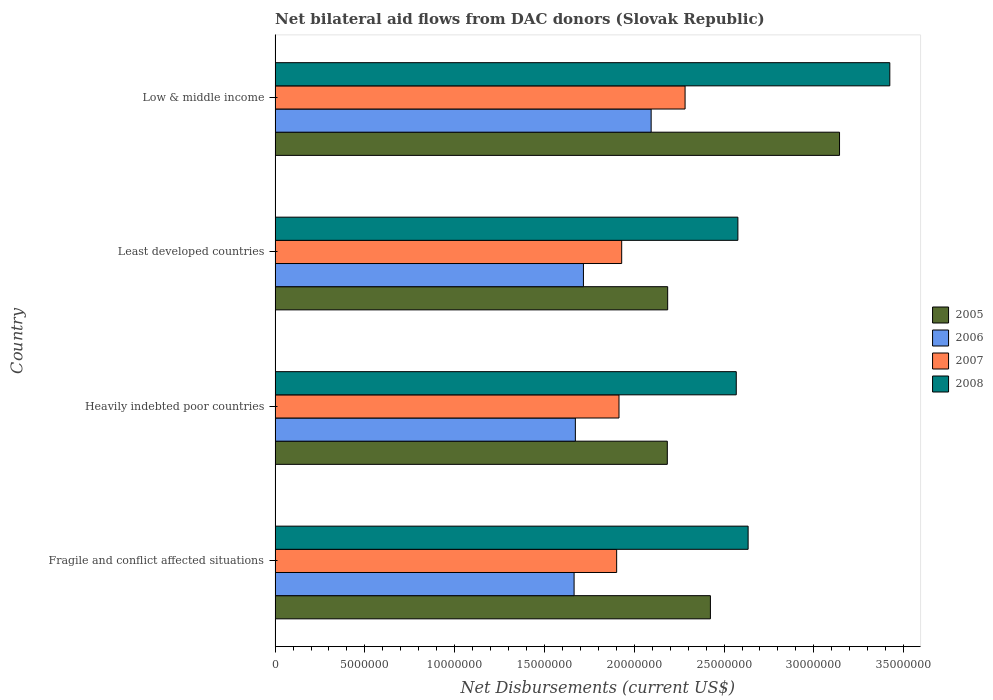How many different coloured bars are there?
Give a very brief answer. 4. Are the number of bars per tick equal to the number of legend labels?
Make the answer very short. Yes. Are the number of bars on each tick of the Y-axis equal?
Your answer should be very brief. Yes. How many bars are there on the 4th tick from the top?
Your response must be concise. 4. What is the label of the 4th group of bars from the top?
Provide a short and direct response. Fragile and conflict affected situations. What is the net bilateral aid flows in 2006 in Heavily indebted poor countries?
Offer a very short reply. 1.67e+07. Across all countries, what is the maximum net bilateral aid flows in 2008?
Offer a terse response. 3.42e+07. Across all countries, what is the minimum net bilateral aid flows in 2008?
Make the answer very short. 2.57e+07. In which country was the net bilateral aid flows in 2006 maximum?
Make the answer very short. Low & middle income. In which country was the net bilateral aid flows in 2006 minimum?
Ensure brevity in your answer.  Fragile and conflict affected situations. What is the total net bilateral aid flows in 2007 in the graph?
Your answer should be compact. 8.03e+07. What is the difference between the net bilateral aid flows in 2006 in Heavily indebted poor countries and that in Least developed countries?
Provide a short and direct response. -4.50e+05. What is the difference between the net bilateral aid flows in 2006 in Fragile and conflict affected situations and the net bilateral aid flows in 2005 in Least developed countries?
Provide a succinct answer. -5.21e+06. What is the average net bilateral aid flows in 2006 per country?
Your answer should be very brief. 1.79e+07. What is the difference between the net bilateral aid flows in 2005 and net bilateral aid flows in 2008 in Fragile and conflict affected situations?
Offer a very short reply. -2.10e+06. In how many countries, is the net bilateral aid flows in 2006 greater than 1000000 US$?
Ensure brevity in your answer.  4. What is the ratio of the net bilateral aid flows in 2005 in Least developed countries to that in Low & middle income?
Your answer should be very brief. 0.7. Is the net bilateral aid flows in 2007 in Fragile and conflict affected situations less than that in Least developed countries?
Your answer should be very brief. Yes. What is the difference between the highest and the second highest net bilateral aid flows in 2008?
Offer a very short reply. 7.89e+06. What is the difference between the highest and the lowest net bilateral aid flows in 2008?
Your response must be concise. 8.55e+06. In how many countries, is the net bilateral aid flows in 2006 greater than the average net bilateral aid flows in 2006 taken over all countries?
Your answer should be compact. 1. Is the sum of the net bilateral aid flows in 2008 in Fragile and conflict affected situations and Least developed countries greater than the maximum net bilateral aid flows in 2005 across all countries?
Offer a very short reply. Yes. Is it the case that in every country, the sum of the net bilateral aid flows in 2008 and net bilateral aid flows in 2007 is greater than the net bilateral aid flows in 2005?
Ensure brevity in your answer.  Yes. Are all the bars in the graph horizontal?
Offer a very short reply. Yes. Does the graph contain grids?
Your answer should be very brief. No. Where does the legend appear in the graph?
Offer a very short reply. Center right. What is the title of the graph?
Ensure brevity in your answer.  Net bilateral aid flows from DAC donors (Slovak Republic). Does "1961" appear as one of the legend labels in the graph?
Give a very brief answer. No. What is the label or title of the X-axis?
Make the answer very short. Net Disbursements (current US$). What is the Net Disbursements (current US$) in 2005 in Fragile and conflict affected situations?
Provide a succinct answer. 2.42e+07. What is the Net Disbursements (current US$) in 2006 in Fragile and conflict affected situations?
Provide a short and direct response. 1.66e+07. What is the Net Disbursements (current US$) in 2007 in Fragile and conflict affected situations?
Ensure brevity in your answer.  1.90e+07. What is the Net Disbursements (current US$) of 2008 in Fragile and conflict affected situations?
Your response must be concise. 2.63e+07. What is the Net Disbursements (current US$) in 2005 in Heavily indebted poor countries?
Your answer should be very brief. 2.18e+07. What is the Net Disbursements (current US$) of 2006 in Heavily indebted poor countries?
Offer a terse response. 1.67e+07. What is the Net Disbursements (current US$) in 2007 in Heavily indebted poor countries?
Offer a terse response. 1.92e+07. What is the Net Disbursements (current US$) in 2008 in Heavily indebted poor countries?
Offer a very short reply. 2.57e+07. What is the Net Disbursements (current US$) in 2005 in Least developed countries?
Make the answer very short. 2.19e+07. What is the Net Disbursements (current US$) of 2006 in Least developed countries?
Ensure brevity in your answer.  1.72e+07. What is the Net Disbursements (current US$) of 2007 in Least developed countries?
Make the answer very short. 1.93e+07. What is the Net Disbursements (current US$) in 2008 in Least developed countries?
Your response must be concise. 2.58e+07. What is the Net Disbursements (current US$) of 2005 in Low & middle income?
Keep it short and to the point. 3.14e+07. What is the Net Disbursements (current US$) in 2006 in Low & middle income?
Provide a succinct answer. 2.09e+07. What is the Net Disbursements (current US$) in 2007 in Low & middle income?
Your answer should be very brief. 2.28e+07. What is the Net Disbursements (current US$) in 2008 in Low & middle income?
Provide a succinct answer. 3.42e+07. Across all countries, what is the maximum Net Disbursements (current US$) of 2005?
Keep it short and to the point. 3.14e+07. Across all countries, what is the maximum Net Disbursements (current US$) of 2006?
Offer a very short reply. 2.09e+07. Across all countries, what is the maximum Net Disbursements (current US$) of 2007?
Offer a very short reply. 2.28e+07. Across all countries, what is the maximum Net Disbursements (current US$) in 2008?
Ensure brevity in your answer.  3.42e+07. Across all countries, what is the minimum Net Disbursements (current US$) of 2005?
Provide a short and direct response. 2.18e+07. Across all countries, what is the minimum Net Disbursements (current US$) of 2006?
Offer a terse response. 1.66e+07. Across all countries, what is the minimum Net Disbursements (current US$) in 2007?
Provide a succinct answer. 1.90e+07. Across all countries, what is the minimum Net Disbursements (current US$) in 2008?
Provide a succinct answer. 2.57e+07. What is the total Net Disbursements (current US$) in 2005 in the graph?
Make the answer very short. 9.94e+07. What is the total Net Disbursements (current US$) of 2006 in the graph?
Provide a succinct answer. 7.15e+07. What is the total Net Disbursements (current US$) of 2007 in the graph?
Provide a short and direct response. 8.03e+07. What is the total Net Disbursements (current US$) of 2008 in the graph?
Ensure brevity in your answer.  1.12e+08. What is the difference between the Net Disbursements (current US$) of 2005 in Fragile and conflict affected situations and that in Heavily indebted poor countries?
Provide a succinct answer. 2.40e+06. What is the difference between the Net Disbursements (current US$) in 2006 in Fragile and conflict affected situations and that in Heavily indebted poor countries?
Make the answer very short. -7.00e+04. What is the difference between the Net Disbursements (current US$) of 2007 in Fragile and conflict affected situations and that in Heavily indebted poor countries?
Provide a short and direct response. -1.30e+05. What is the difference between the Net Disbursements (current US$) of 2008 in Fragile and conflict affected situations and that in Heavily indebted poor countries?
Ensure brevity in your answer.  6.60e+05. What is the difference between the Net Disbursements (current US$) of 2005 in Fragile and conflict affected situations and that in Least developed countries?
Provide a succinct answer. 2.38e+06. What is the difference between the Net Disbursements (current US$) of 2006 in Fragile and conflict affected situations and that in Least developed countries?
Your answer should be very brief. -5.20e+05. What is the difference between the Net Disbursements (current US$) in 2007 in Fragile and conflict affected situations and that in Least developed countries?
Ensure brevity in your answer.  -2.80e+05. What is the difference between the Net Disbursements (current US$) of 2008 in Fragile and conflict affected situations and that in Least developed countries?
Make the answer very short. 5.70e+05. What is the difference between the Net Disbursements (current US$) in 2005 in Fragile and conflict affected situations and that in Low & middle income?
Provide a succinct answer. -7.19e+06. What is the difference between the Net Disbursements (current US$) in 2006 in Fragile and conflict affected situations and that in Low & middle income?
Offer a terse response. -4.29e+06. What is the difference between the Net Disbursements (current US$) of 2007 in Fragile and conflict affected situations and that in Low & middle income?
Offer a very short reply. -3.81e+06. What is the difference between the Net Disbursements (current US$) of 2008 in Fragile and conflict affected situations and that in Low & middle income?
Make the answer very short. -7.89e+06. What is the difference between the Net Disbursements (current US$) in 2006 in Heavily indebted poor countries and that in Least developed countries?
Give a very brief answer. -4.50e+05. What is the difference between the Net Disbursements (current US$) in 2007 in Heavily indebted poor countries and that in Least developed countries?
Provide a short and direct response. -1.50e+05. What is the difference between the Net Disbursements (current US$) in 2005 in Heavily indebted poor countries and that in Low & middle income?
Keep it short and to the point. -9.59e+06. What is the difference between the Net Disbursements (current US$) of 2006 in Heavily indebted poor countries and that in Low & middle income?
Offer a terse response. -4.22e+06. What is the difference between the Net Disbursements (current US$) in 2007 in Heavily indebted poor countries and that in Low & middle income?
Your answer should be very brief. -3.68e+06. What is the difference between the Net Disbursements (current US$) in 2008 in Heavily indebted poor countries and that in Low & middle income?
Ensure brevity in your answer.  -8.55e+06. What is the difference between the Net Disbursements (current US$) of 2005 in Least developed countries and that in Low & middle income?
Provide a short and direct response. -9.57e+06. What is the difference between the Net Disbursements (current US$) of 2006 in Least developed countries and that in Low & middle income?
Make the answer very short. -3.77e+06. What is the difference between the Net Disbursements (current US$) in 2007 in Least developed countries and that in Low & middle income?
Keep it short and to the point. -3.53e+06. What is the difference between the Net Disbursements (current US$) in 2008 in Least developed countries and that in Low & middle income?
Provide a succinct answer. -8.46e+06. What is the difference between the Net Disbursements (current US$) in 2005 in Fragile and conflict affected situations and the Net Disbursements (current US$) in 2006 in Heavily indebted poor countries?
Your answer should be compact. 7.52e+06. What is the difference between the Net Disbursements (current US$) of 2005 in Fragile and conflict affected situations and the Net Disbursements (current US$) of 2007 in Heavily indebted poor countries?
Your response must be concise. 5.09e+06. What is the difference between the Net Disbursements (current US$) of 2005 in Fragile and conflict affected situations and the Net Disbursements (current US$) of 2008 in Heavily indebted poor countries?
Provide a succinct answer. -1.44e+06. What is the difference between the Net Disbursements (current US$) of 2006 in Fragile and conflict affected situations and the Net Disbursements (current US$) of 2007 in Heavily indebted poor countries?
Your answer should be very brief. -2.50e+06. What is the difference between the Net Disbursements (current US$) of 2006 in Fragile and conflict affected situations and the Net Disbursements (current US$) of 2008 in Heavily indebted poor countries?
Provide a succinct answer. -9.03e+06. What is the difference between the Net Disbursements (current US$) of 2007 in Fragile and conflict affected situations and the Net Disbursements (current US$) of 2008 in Heavily indebted poor countries?
Your answer should be very brief. -6.66e+06. What is the difference between the Net Disbursements (current US$) of 2005 in Fragile and conflict affected situations and the Net Disbursements (current US$) of 2006 in Least developed countries?
Keep it short and to the point. 7.07e+06. What is the difference between the Net Disbursements (current US$) in 2005 in Fragile and conflict affected situations and the Net Disbursements (current US$) in 2007 in Least developed countries?
Your answer should be compact. 4.94e+06. What is the difference between the Net Disbursements (current US$) of 2005 in Fragile and conflict affected situations and the Net Disbursements (current US$) of 2008 in Least developed countries?
Make the answer very short. -1.53e+06. What is the difference between the Net Disbursements (current US$) of 2006 in Fragile and conflict affected situations and the Net Disbursements (current US$) of 2007 in Least developed countries?
Your answer should be very brief. -2.65e+06. What is the difference between the Net Disbursements (current US$) in 2006 in Fragile and conflict affected situations and the Net Disbursements (current US$) in 2008 in Least developed countries?
Your answer should be compact. -9.12e+06. What is the difference between the Net Disbursements (current US$) of 2007 in Fragile and conflict affected situations and the Net Disbursements (current US$) of 2008 in Least developed countries?
Offer a terse response. -6.75e+06. What is the difference between the Net Disbursements (current US$) in 2005 in Fragile and conflict affected situations and the Net Disbursements (current US$) in 2006 in Low & middle income?
Offer a very short reply. 3.30e+06. What is the difference between the Net Disbursements (current US$) of 2005 in Fragile and conflict affected situations and the Net Disbursements (current US$) of 2007 in Low & middle income?
Keep it short and to the point. 1.41e+06. What is the difference between the Net Disbursements (current US$) of 2005 in Fragile and conflict affected situations and the Net Disbursements (current US$) of 2008 in Low & middle income?
Give a very brief answer. -9.99e+06. What is the difference between the Net Disbursements (current US$) of 2006 in Fragile and conflict affected situations and the Net Disbursements (current US$) of 2007 in Low & middle income?
Offer a very short reply. -6.18e+06. What is the difference between the Net Disbursements (current US$) of 2006 in Fragile and conflict affected situations and the Net Disbursements (current US$) of 2008 in Low & middle income?
Give a very brief answer. -1.76e+07. What is the difference between the Net Disbursements (current US$) in 2007 in Fragile and conflict affected situations and the Net Disbursements (current US$) in 2008 in Low & middle income?
Provide a succinct answer. -1.52e+07. What is the difference between the Net Disbursements (current US$) in 2005 in Heavily indebted poor countries and the Net Disbursements (current US$) in 2006 in Least developed countries?
Give a very brief answer. 4.67e+06. What is the difference between the Net Disbursements (current US$) of 2005 in Heavily indebted poor countries and the Net Disbursements (current US$) of 2007 in Least developed countries?
Keep it short and to the point. 2.54e+06. What is the difference between the Net Disbursements (current US$) of 2005 in Heavily indebted poor countries and the Net Disbursements (current US$) of 2008 in Least developed countries?
Offer a very short reply. -3.93e+06. What is the difference between the Net Disbursements (current US$) in 2006 in Heavily indebted poor countries and the Net Disbursements (current US$) in 2007 in Least developed countries?
Your answer should be compact. -2.58e+06. What is the difference between the Net Disbursements (current US$) of 2006 in Heavily indebted poor countries and the Net Disbursements (current US$) of 2008 in Least developed countries?
Your answer should be compact. -9.05e+06. What is the difference between the Net Disbursements (current US$) of 2007 in Heavily indebted poor countries and the Net Disbursements (current US$) of 2008 in Least developed countries?
Offer a very short reply. -6.62e+06. What is the difference between the Net Disbursements (current US$) in 2005 in Heavily indebted poor countries and the Net Disbursements (current US$) in 2007 in Low & middle income?
Your answer should be compact. -9.90e+05. What is the difference between the Net Disbursements (current US$) in 2005 in Heavily indebted poor countries and the Net Disbursements (current US$) in 2008 in Low & middle income?
Offer a terse response. -1.24e+07. What is the difference between the Net Disbursements (current US$) in 2006 in Heavily indebted poor countries and the Net Disbursements (current US$) in 2007 in Low & middle income?
Give a very brief answer. -6.11e+06. What is the difference between the Net Disbursements (current US$) of 2006 in Heavily indebted poor countries and the Net Disbursements (current US$) of 2008 in Low & middle income?
Make the answer very short. -1.75e+07. What is the difference between the Net Disbursements (current US$) of 2007 in Heavily indebted poor countries and the Net Disbursements (current US$) of 2008 in Low & middle income?
Your answer should be compact. -1.51e+07. What is the difference between the Net Disbursements (current US$) in 2005 in Least developed countries and the Net Disbursements (current US$) in 2006 in Low & middle income?
Make the answer very short. 9.20e+05. What is the difference between the Net Disbursements (current US$) of 2005 in Least developed countries and the Net Disbursements (current US$) of 2007 in Low & middle income?
Give a very brief answer. -9.70e+05. What is the difference between the Net Disbursements (current US$) in 2005 in Least developed countries and the Net Disbursements (current US$) in 2008 in Low & middle income?
Ensure brevity in your answer.  -1.24e+07. What is the difference between the Net Disbursements (current US$) in 2006 in Least developed countries and the Net Disbursements (current US$) in 2007 in Low & middle income?
Give a very brief answer. -5.66e+06. What is the difference between the Net Disbursements (current US$) of 2006 in Least developed countries and the Net Disbursements (current US$) of 2008 in Low & middle income?
Provide a short and direct response. -1.71e+07. What is the difference between the Net Disbursements (current US$) of 2007 in Least developed countries and the Net Disbursements (current US$) of 2008 in Low & middle income?
Your answer should be very brief. -1.49e+07. What is the average Net Disbursements (current US$) in 2005 per country?
Keep it short and to the point. 2.48e+07. What is the average Net Disbursements (current US$) in 2006 per country?
Keep it short and to the point. 1.79e+07. What is the average Net Disbursements (current US$) in 2007 per country?
Provide a short and direct response. 2.01e+07. What is the average Net Disbursements (current US$) of 2008 per country?
Make the answer very short. 2.80e+07. What is the difference between the Net Disbursements (current US$) in 2005 and Net Disbursements (current US$) in 2006 in Fragile and conflict affected situations?
Your answer should be compact. 7.59e+06. What is the difference between the Net Disbursements (current US$) in 2005 and Net Disbursements (current US$) in 2007 in Fragile and conflict affected situations?
Offer a terse response. 5.22e+06. What is the difference between the Net Disbursements (current US$) in 2005 and Net Disbursements (current US$) in 2008 in Fragile and conflict affected situations?
Offer a terse response. -2.10e+06. What is the difference between the Net Disbursements (current US$) in 2006 and Net Disbursements (current US$) in 2007 in Fragile and conflict affected situations?
Your answer should be very brief. -2.37e+06. What is the difference between the Net Disbursements (current US$) in 2006 and Net Disbursements (current US$) in 2008 in Fragile and conflict affected situations?
Your answer should be compact. -9.69e+06. What is the difference between the Net Disbursements (current US$) of 2007 and Net Disbursements (current US$) of 2008 in Fragile and conflict affected situations?
Offer a terse response. -7.32e+06. What is the difference between the Net Disbursements (current US$) of 2005 and Net Disbursements (current US$) of 2006 in Heavily indebted poor countries?
Offer a terse response. 5.12e+06. What is the difference between the Net Disbursements (current US$) in 2005 and Net Disbursements (current US$) in 2007 in Heavily indebted poor countries?
Offer a terse response. 2.69e+06. What is the difference between the Net Disbursements (current US$) of 2005 and Net Disbursements (current US$) of 2008 in Heavily indebted poor countries?
Your response must be concise. -3.84e+06. What is the difference between the Net Disbursements (current US$) of 2006 and Net Disbursements (current US$) of 2007 in Heavily indebted poor countries?
Your answer should be very brief. -2.43e+06. What is the difference between the Net Disbursements (current US$) of 2006 and Net Disbursements (current US$) of 2008 in Heavily indebted poor countries?
Offer a terse response. -8.96e+06. What is the difference between the Net Disbursements (current US$) in 2007 and Net Disbursements (current US$) in 2008 in Heavily indebted poor countries?
Keep it short and to the point. -6.53e+06. What is the difference between the Net Disbursements (current US$) in 2005 and Net Disbursements (current US$) in 2006 in Least developed countries?
Your answer should be compact. 4.69e+06. What is the difference between the Net Disbursements (current US$) in 2005 and Net Disbursements (current US$) in 2007 in Least developed countries?
Provide a succinct answer. 2.56e+06. What is the difference between the Net Disbursements (current US$) of 2005 and Net Disbursements (current US$) of 2008 in Least developed countries?
Keep it short and to the point. -3.91e+06. What is the difference between the Net Disbursements (current US$) of 2006 and Net Disbursements (current US$) of 2007 in Least developed countries?
Give a very brief answer. -2.13e+06. What is the difference between the Net Disbursements (current US$) of 2006 and Net Disbursements (current US$) of 2008 in Least developed countries?
Keep it short and to the point. -8.60e+06. What is the difference between the Net Disbursements (current US$) in 2007 and Net Disbursements (current US$) in 2008 in Least developed countries?
Your answer should be very brief. -6.47e+06. What is the difference between the Net Disbursements (current US$) in 2005 and Net Disbursements (current US$) in 2006 in Low & middle income?
Offer a very short reply. 1.05e+07. What is the difference between the Net Disbursements (current US$) in 2005 and Net Disbursements (current US$) in 2007 in Low & middle income?
Make the answer very short. 8.60e+06. What is the difference between the Net Disbursements (current US$) of 2005 and Net Disbursements (current US$) of 2008 in Low & middle income?
Your answer should be very brief. -2.80e+06. What is the difference between the Net Disbursements (current US$) in 2006 and Net Disbursements (current US$) in 2007 in Low & middle income?
Give a very brief answer. -1.89e+06. What is the difference between the Net Disbursements (current US$) of 2006 and Net Disbursements (current US$) of 2008 in Low & middle income?
Make the answer very short. -1.33e+07. What is the difference between the Net Disbursements (current US$) of 2007 and Net Disbursements (current US$) of 2008 in Low & middle income?
Offer a terse response. -1.14e+07. What is the ratio of the Net Disbursements (current US$) in 2005 in Fragile and conflict affected situations to that in Heavily indebted poor countries?
Your response must be concise. 1.11. What is the ratio of the Net Disbursements (current US$) of 2006 in Fragile and conflict affected situations to that in Heavily indebted poor countries?
Keep it short and to the point. 1. What is the ratio of the Net Disbursements (current US$) in 2007 in Fragile and conflict affected situations to that in Heavily indebted poor countries?
Offer a very short reply. 0.99. What is the ratio of the Net Disbursements (current US$) in 2008 in Fragile and conflict affected situations to that in Heavily indebted poor countries?
Offer a very short reply. 1.03. What is the ratio of the Net Disbursements (current US$) of 2005 in Fragile and conflict affected situations to that in Least developed countries?
Your response must be concise. 1.11. What is the ratio of the Net Disbursements (current US$) of 2006 in Fragile and conflict affected situations to that in Least developed countries?
Offer a terse response. 0.97. What is the ratio of the Net Disbursements (current US$) of 2007 in Fragile and conflict affected situations to that in Least developed countries?
Offer a very short reply. 0.99. What is the ratio of the Net Disbursements (current US$) of 2008 in Fragile and conflict affected situations to that in Least developed countries?
Your answer should be very brief. 1.02. What is the ratio of the Net Disbursements (current US$) in 2005 in Fragile and conflict affected situations to that in Low & middle income?
Offer a very short reply. 0.77. What is the ratio of the Net Disbursements (current US$) of 2006 in Fragile and conflict affected situations to that in Low & middle income?
Ensure brevity in your answer.  0.8. What is the ratio of the Net Disbursements (current US$) in 2007 in Fragile and conflict affected situations to that in Low & middle income?
Ensure brevity in your answer.  0.83. What is the ratio of the Net Disbursements (current US$) in 2008 in Fragile and conflict affected situations to that in Low & middle income?
Provide a succinct answer. 0.77. What is the ratio of the Net Disbursements (current US$) of 2006 in Heavily indebted poor countries to that in Least developed countries?
Ensure brevity in your answer.  0.97. What is the ratio of the Net Disbursements (current US$) in 2007 in Heavily indebted poor countries to that in Least developed countries?
Offer a terse response. 0.99. What is the ratio of the Net Disbursements (current US$) in 2005 in Heavily indebted poor countries to that in Low & middle income?
Provide a short and direct response. 0.69. What is the ratio of the Net Disbursements (current US$) of 2006 in Heavily indebted poor countries to that in Low & middle income?
Your answer should be compact. 0.8. What is the ratio of the Net Disbursements (current US$) in 2007 in Heavily indebted poor countries to that in Low & middle income?
Provide a short and direct response. 0.84. What is the ratio of the Net Disbursements (current US$) in 2008 in Heavily indebted poor countries to that in Low & middle income?
Your answer should be very brief. 0.75. What is the ratio of the Net Disbursements (current US$) in 2005 in Least developed countries to that in Low & middle income?
Ensure brevity in your answer.  0.7. What is the ratio of the Net Disbursements (current US$) of 2006 in Least developed countries to that in Low & middle income?
Provide a succinct answer. 0.82. What is the ratio of the Net Disbursements (current US$) in 2007 in Least developed countries to that in Low & middle income?
Ensure brevity in your answer.  0.85. What is the ratio of the Net Disbursements (current US$) in 2008 in Least developed countries to that in Low & middle income?
Make the answer very short. 0.75. What is the difference between the highest and the second highest Net Disbursements (current US$) in 2005?
Provide a succinct answer. 7.19e+06. What is the difference between the highest and the second highest Net Disbursements (current US$) in 2006?
Your response must be concise. 3.77e+06. What is the difference between the highest and the second highest Net Disbursements (current US$) in 2007?
Ensure brevity in your answer.  3.53e+06. What is the difference between the highest and the second highest Net Disbursements (current US$) of 2008?
Your answer should be compact. 7.89e+06. What is the difference between the highest and the lowest Net Disbursements (current US$) of 2005?
Make the answer very short. 9.59e+06. What is the difference between the highest and the lowest Net Disbursements (current US$) in 2006?
Make the answer very short. 4.29e+06. What is the difference between the highest and the lowest Net Disbursements (current US$) of 2007?
Give a very brief answer. 3.81e+06. What is the difference between the highest and the lowest Net Disbursements (current US$) in 2008?
Offer a very short reply. 8.55e+06. 